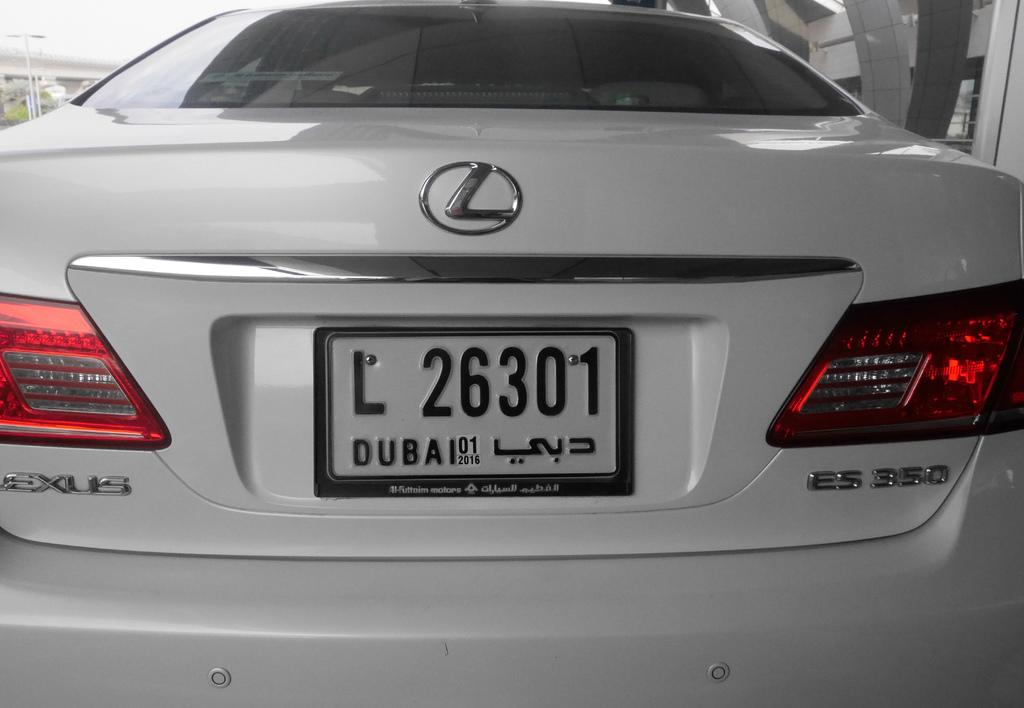What is the main subject of the image? There is a car in the image. What can be seen in the background of the image? There are poles, plants, a building, a bridge, and the sky visible in the background of the image. Can you describe the setting of the image? The image appears to be taken in an urban or suburban area, with a car, buildings, and a bridge visible. How many ducks are swimming in the river under the bridge in the image? There are no ducks or rivers visible in the image; it features a car and various elements in the background. 